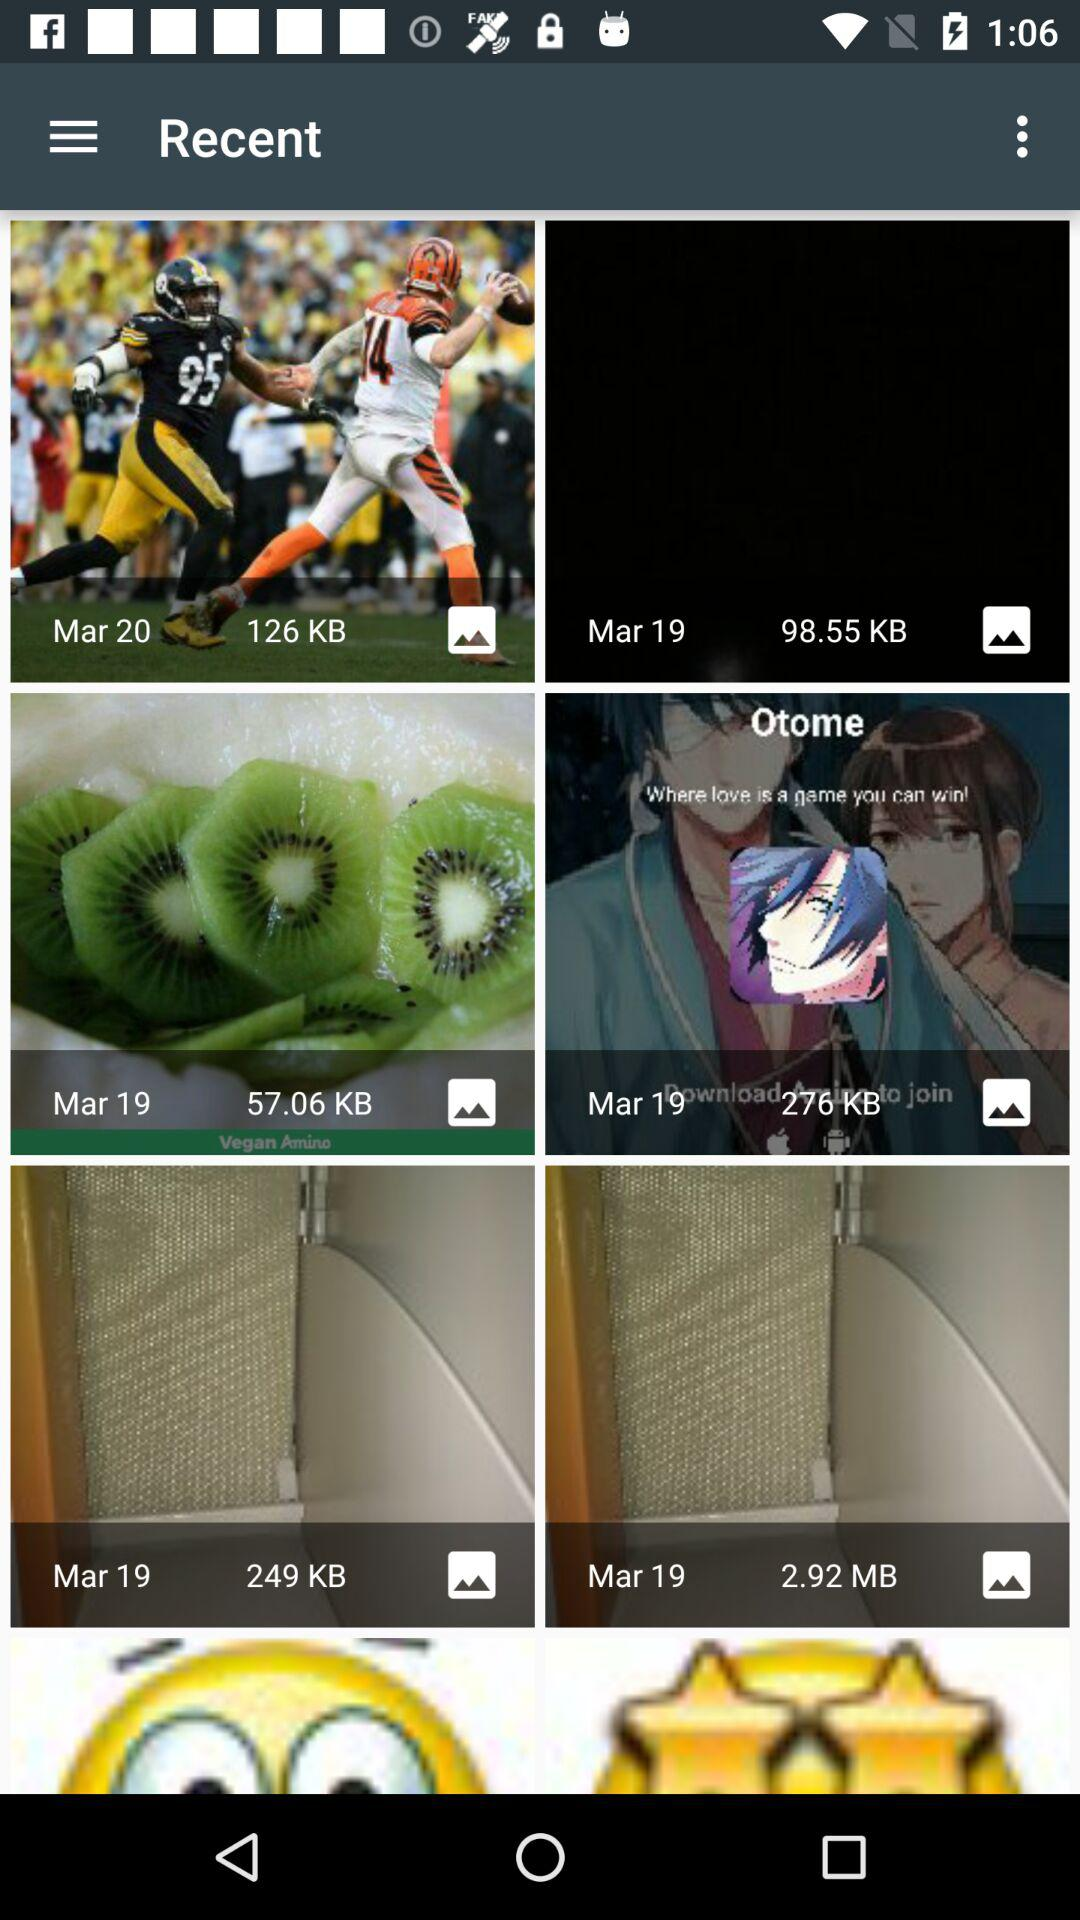What is the size of the photo that was saved on March 20? The size of the photo is 126 KB. 